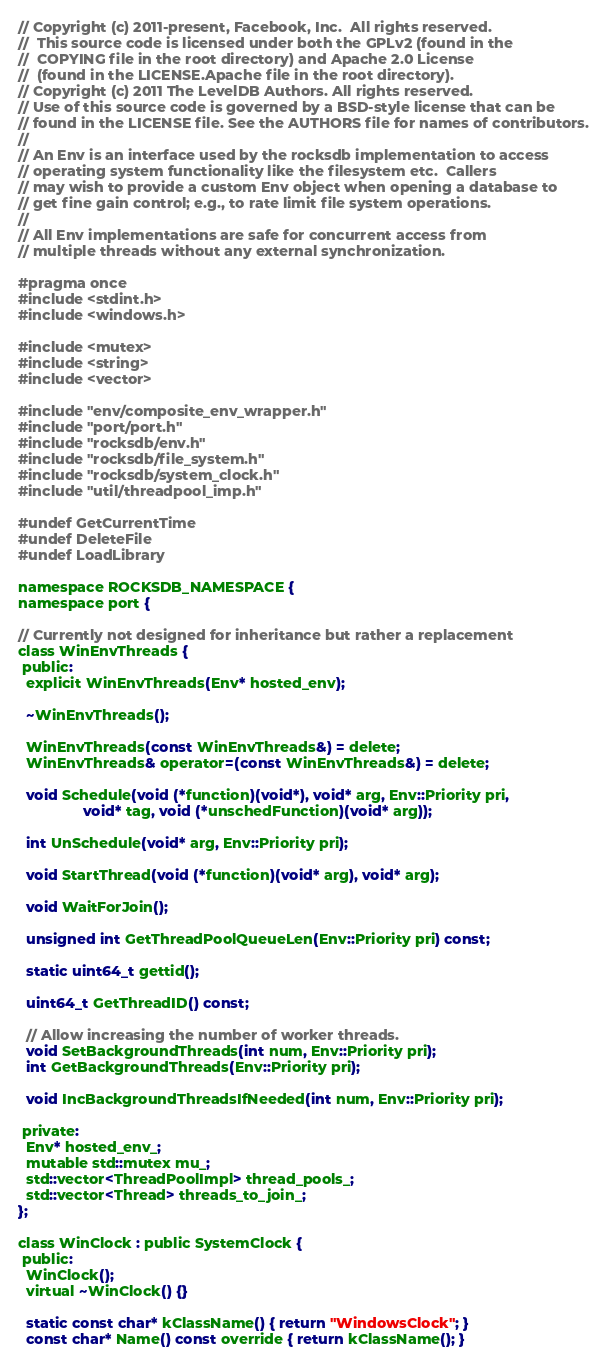<code> <loc_0><loc_0><loc_500><loc_500><_C_>// Copyright (c) 2011-present, Facebook, Inc.  All rights reserved.
//  This source code is licensed under both the GPLv2 (found in the
//  COPYING file in the root directory) and Apache 2.0 License
//  (found in the LICENSE.Apache file in the root directory).
// Copyright (c) 2011 The LevelDB Authors. All rights reserved.
// Use of this source code is governed by a BSD-style license that can be
// found in the LICENSE file. See the AUTHORS file for names of contributors.
//
// An Env is an interface used by the rocksdb implementation to access
// operating system functionality like the filesystem etc.  Callers
// may wish to provide a custom Env object when opening a database to
// get fine gain control; e.g., to rate limit file system operations.
//
// All Env implementations are safe for concurrent access from
// multiple threads without any external synchronization.

#pragma once
#include <stdint.h>
#include <windows.h>

#include <mutex>
#include <string>
#include <vector>

#include "env/composite_env_wrapper.h"
#include "port/port.h"
#include "rocksdb/env.h"
#include "rocksdb/file_system.h"
#include "rocksdb/system_clock.h"
#include "util/threadpool_imp.h"

#undef GetCurrentTime
#undef DeleteFile
#undef LoadLibrary

namespace ROCKSDB_NAMESPACE {
namespace port {

// Currently not designed for inheritance but rather a replacement
class WinEnvThreads {
 public:
  explicit WinEnvThreads(Env* hosted_env);

  ~WinEnvThreads();

  WinEnvThreads(const WinEnvThreads&) = delete;
  WinEnvThreads& operator=(const WinEnvThreads&) = delete;

  void Schedule(void (*function)(void*), void* arg, Env::Priority pri,
                void* tag, void (*unschedFunction)(void* arg));

  int UnSchedule(void* arg, Env::Priority pri);

  void StartThread(void (*function)(void* arg), void* arg);

  void WaitForJoin();

  unsigned int GetThreadPoolQueueLen(Env::Priority pri) const;

  static uint64_t gettid();

  uint64_t GetThreadID() const;

  // Allow increasing the number of worker threads.
  void SetBackgroundThreads(int num, Env::Priority pri);
  int GetBackgroundThreads(Env::Priority pri);

  void IncBackgroundThreadsIfNeeded(int num, Env::Priority pri);

 private:
  Env* hosted_env_;
  mutable std::mutex mu_;
  std::vector<ThreadPoolImpl> thread_pools_;
  std::vector<Thread> threads_to_join_;
};

class WinClock : public SystemClock {
 public:
  WinClock();
  virtual ~WinClock() {}

  static const char* kClassName() { return "WindowsClock"; }
  const char* Name() const override { return kClassName(); }</code> 